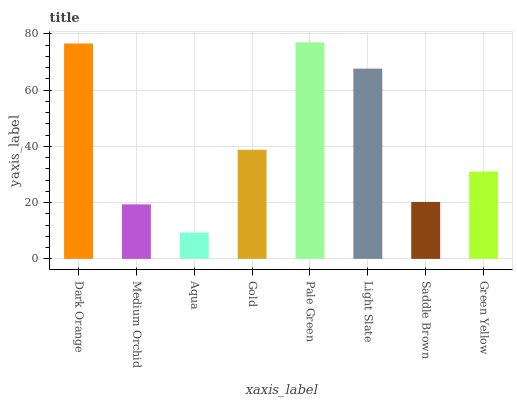Is Aqua the minimum?
Answer yes or no. Yes. Is Pale Green the maximum?
Answer yes or no. Yes. Is Medium Orchid the minimum?
Answer yes or no. No. Is Medium Orchid the maximum?
Answer yes or no. No. Is Dark Orange greater than Medium Orchid?
Answer yes or no. Yes. Is Medium Orchid less than Dark Orange?
Answer yes or no. Yes. Is Medium Orchid greater than Dark Orange?
Answer yes or no. No. Is Dark Orange less than Medium Orchid?
Answer yes or no. No. Is Gold the high median?
Answer yes or no. Yes. Is Green Yellow the low median?
Answer yes or no. Yes. Is Green Yellow the high median?
Answer yes or no. No. Is Gold the low median?
Answer yes or no. No. 